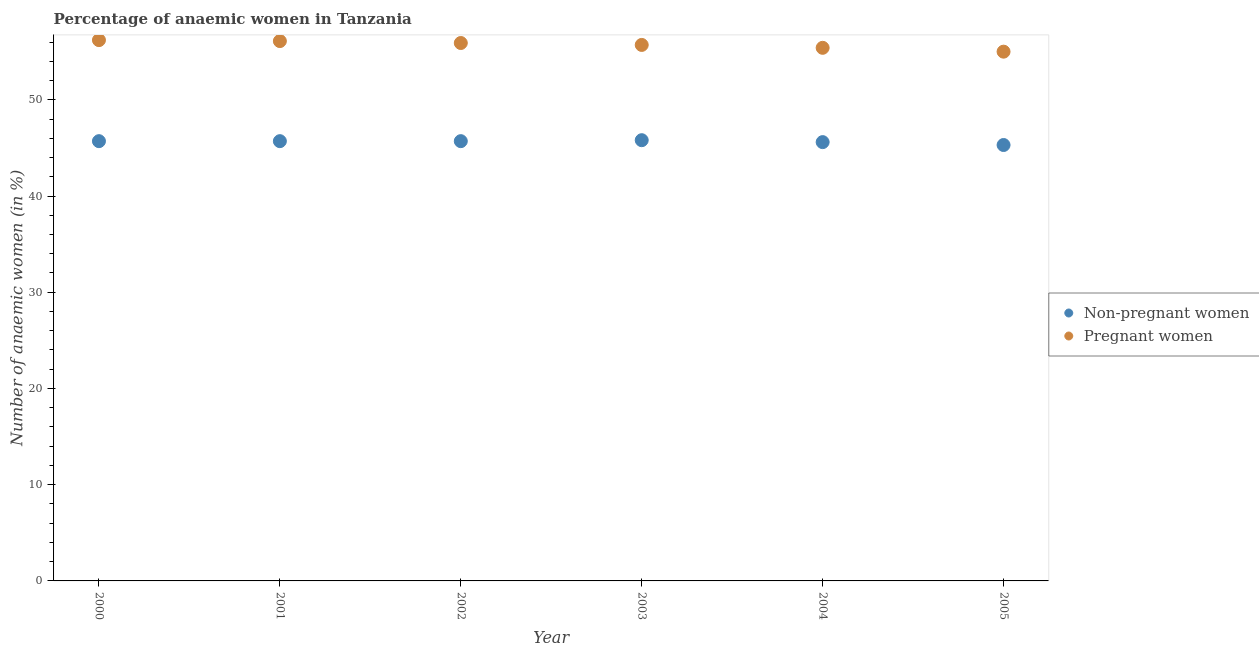Is the number of dotlines equal to the number of legend labels?
Your answer should be compact. Yes. What is the percentage of non-pregnant anaemic women in 2005?
Your answer should be compact. 45.3. Across all years, what is the maximum percentage of non-pregnant anaemic women?
Give a very brief answer. 45.8. Across all years, what is the minimum percentage of non-pregnant anaemic women?
Give a very brief answer. 45.3. In which year was the percentage of non-pregnant anaemic women minimum?
Offer a terse response. 2005. What is the total percentage of non-pregnant anaemic women in the graph?
Provide a succinct answer. 273.8. What is the difference between the percentage of pregnant anaemic women in 2000 and that in 2005?
Give a very brief answer. 1.2. What is the difference between the percentage of non-pregnant anaemic women in 2001 and the percentage of pregnant anaemic women in 2004?
Provide a succinct answer. -9.7. What is the average percentage of non-pregnant anaemic women per year?
Provide a succinct answer. 45.63. In the year 2005, what is the difference between the percentage of pregnant anaemic women and percentage of non-pregnant anaemic women?
Ensure brevity in your answer.  9.7. What is the ratio of the percentage of pregnant anaemic women in 2004 to that in 2005?
Provide a short and direct response. 1.01. Is the percentage of pregnant anaemic women in 2000 less than that in 2005?
Your answer should be compact. No. Is the difference between the percentage of non-pregnant anaemic women in 2001 and 2003 greater than the difference between the percentage of pregnant anaemic women in 2001 and 2003?
Your response must be concise. No. What is the difference between the highest and the second highest percentage of non-pregnant anaemic women?
Keep it short and to the point. 0.1. What is the difference between the highest and the lowest percentage of pregnant anaemic women?
Ensure brevity in your answer.  1.2. In how many years, is the percentage of non-pregnant anaemic women greater than the average percentage of non-pregnant anaemic women taken over all years?
Your answer should be very brief. 4. Is the sum of the percentage of non-pregnant anaemic women in 2000 and 2001 greater than the maximum percentage of pregnant anaemic women across all years?
Your response must be concise. Yes. Is the percentage of non-pregnant anaemic women strictly greater than the percentage of pregnant anaemic women over the years?
Keep it short and to the point. No. Is the percentage of non-pregnant anaemic women strictly less than the percentage of pregnant anaemic women over the years?
Your answer should be very brief. Yes. How many dotlines are there?
Offer a very short reply. 2. What is the difference between two consecutive major ticks on the Y-axis?
Ensure brevity in your answer.  10. Are the values on the major ticks of Y-axis written in scientific E-notation?
Offer a very short reply. No. Does the graph contain any zero values?
Give a very brief answer. No. Does the graph contain grids?
Your answer should be compact. No. How many legend labels are there?
Give a very brief answer. 2. How are the legend labels stacked?
Give a very brief answer. Vertical. What is the title of the graph?
Offer a terse response. Percentage of anaemic women in Tanzania. What is the label or title of the Y-axis?
Provide a succinct answer. Number of anaemic women (in %). What is the Number of anaemic women (in %) of Non-pregnant women in 2000?
Make the answer very short. 45.7. What is the Number of anaemic women (in %) of Pregnant women in 2000?
Your answer should be compact. 56.2. What is the Number of anaemic women (in %) of Non-pregnant women in 2001?
Provide a succinct answer. 45.7. What is the Number of anaemic women (in %) in Pregnant women in 2001?
Your response must be concise. 56.1. What is the Number of anaemic women (in %) of Non-pregnant women in 2002?
Offer a very short reply. 45.7. What is the Number of anaemic women (in %) in Pregnant women in 2002?
Ensure brevity in your answer.  55.9. What is the Number of anaemic women (in %) of Non-pregnant women in 2003?
Ensure brevity in your answer.  45.8. What is the Number of anaemic women (in %) of Pregnant women in 2003?
Your answer should be very brief. 55.7. What is the Number of anaemic women (in %) of Non-pregnant women in 2004?
Offer a terse response. 45.6. What is the Number of anaemic women (in %) of Pregnant women in 2004?
Provide a short and direct response. 55.4. What is the Number of anaemic women (in %) of Non-pregnant women in 2005?
Offer a very short reply. 45.3. What is the Number of anaemic women (in %) in Pregnant women in 2005?
Make the answer very short. 55. Across all years, what is the maximum Number of anaemic women (in %) of Non-pregnant women?
Keep it short and to the point. 45.8. Across all years, what is the maximum Number of anaemic women (in %) of Pregnant women?
Offer a terse response. 56.2. Across all years, what is the minimum Number of anaemic women (in %) of Non-pregnant women?
Ensure brevity in your answer.  45.3. What is the total Number of anaemic women (in %) of Non-pregnant women in the graph?
Your answer should be compact. 273.8. What is the total Number of anaemic women (in %) in Pregnant women in the graph?
Your answer should be very brief. 334.3. What is the difference between the Number of anaemic women (in %) in Pregnant women in 2000 and that in 2001?
Ensure brevity in your answer.  0.1. What is the difference between the Number of anaemic women (in %) in Pregnant women in 2000 and that in 2002?
Provide a succinct answer. 0.3. What is the difference between the Number of anaemic women (in %) of Pregnant women in 2000 and that in 2003?
Offer a very short reply. 0.5. What is the difference between the Number of anaemic women (in %) in Non-pregnant women in 2000 and that in 2004?
Provide a succinct answer. 0.1. What is the difference between the Number of anaemic women (in %) of Pregnant women in 2000 and that in 2004?
Give a very brief answer. 0.8. What is the difference between the Number of anaemic women (in %) in Pregnant women in 2000 and that in 2005?
Your answer should be very brief. 1.2. What is the difference between the Number of anaemic women (in %) in Non-pregnant women in 2001 and that in 2004?
Keep it short and to the point. 0.1. What is the difference between the Number of anaemic women (in %) of Pregnant women in 2001 and that in 2004?
Provide a succinct answer. 0.7. What is the difference between the Number of anaemic women (in %) of Non-pregnant women in 2002 and that in 2005?
Keep it short and to the point. 0.4. What is the difference between the Number of anaemic women (in %) of Pregnant women in 2002 and that in 2005?
Your answer should be compact. 0.9. What is the difference between the Number of anaemic women (in %) of Non-pregnant women in 2003 and that in 2004?
Your response must be concise. 0.2. What is the difference between the Number of anaemic women (in %) in Pregnant women in 2003 and that in 2004?
Provide a short and direct response. 0.3. What is the difference between the Number of anaemic women (in %) of Non-pregnant women in 2003 and that in 2005?
Give a very brief answer. 0.5. What is the difference between the Number of anaemic women (in %) of Non-pregnant women in 2004 and that in 2005?
Your response must be concise. 0.3. What is the difference between the Number of anaemic women (in %) of Pregnant women in 2004 and that in 2005?
Provide a succinct answer. 0.4. What is the difference between the Number of anaemic women (in %) in Non-pregnant women in 2000 and the Number of anaemic women (in %) in Pregnant women in 2002?
Your answer should be very brief. -10.2. What is the difference between the Number of anaemic women (in %) of Non-pregnant women in 2000 and the Number of anaemic women (in %) of Pregnant women in 2003?
Keep it short and to the point. -10. What is the difference between the Number of anaemic women (in %) in Non-pregnant women in 2000 and the Number of anaemic women (in %) in Pregnant women in 2005?
Keep it short and to the point. -9.3. What is the difference between the Number of anaemic women (in %) in Non-pregnant women in 2001 and the Number of anaemic women (in %) in Pregnant women in 2003?
Your answer should be very brief. -10. What is the difference between the Number of anaemic women (in %) in Non-pregnant women in 2001 and the Number of anaemic women (in %) in Pregnant women in 2004?
Your response must be concise. -9.7. What is the difference between the Number of anaemic women (in %) in Non-pregnant women in 2003 and the Number of anaemic women (in %) in Pregnant women in 2004?
Your answer should be very brief. -9.6. What is the difference between the Number of anaemic women (in %) of Non-pregnant women in 2004 and the Number of anaemic women (in %) of Pregnant women in 2005?
Ensure brevity in your answer.  -9.4. What is the average Number of anaemic women (in %) of Non-pregnant women per year?
Offer a terse response. 45.63. What is the average Number of anaemic women (in %) of Pregnant women per year?
Your response must be concise. 55.72. In the year 2000, what is the difference between the Number of anaemic women (in %) of Non-pregnant women and Number of anaemic women (in %) of Pregnant women?
Provide a succinct answer. -10.5. In the year 2003, what is the difference between the Number of anaemic women (in %) of Non-pregnant women and Number of anaemic women (in %) of Pregnant women?
Make the answer very short. -9.9. What is the ratio of the Number of anaemic women (in %) of Non-pregnant women in 2000 to that in 2001?
Ensure brevity in your answer.  1. What is the ratio of the Number of anaemic women (in %) of Pregnant women in 2000 to that in 2001?
Provide a succinct answer. 1. What is the ratio of the Number of anaemic women (in %) of Pregnant women in 2000 to that in 2002?
Offer a very short reply. 1.01. What is the ratio of the Number of anaemic women (in %) of Non-pregnant women in 2000 to that in 2003?
Offer a very short reply. 1. What is the ratio of the Number of anaemic women (in %) of Pregnant women in 2000 to that in 2003?
Your answer should be compact. 1.01. What is the ratio of the Number of anaemic women (in %) of Pregnant women in 2000 to that in 2004?
Provide a succinct answer. 1.01. What is the ratio of the Number of anaemic women (in %) of Non-pregnant women in 2000 to that in 2005?
Keep it short and to the point. 1.01. What is the ratio of the Number of anaemic women (in %) of Pregnant women in 2000 to that in 2005?
Offer a terse response. 1.02. What is the ratio of the Number of anaemic women (in %) of Pregnant women in 2001 to that in 2003?
Your response must be concise. 1.01. What is the ratio of the Number of anaemic women (in %) in Pregnant women in 2001 to that in 2004?
Make the answer very short. 1.01. What is the ratio of the Number of anaemic women (in %) in Non-pregnant women in 2001 to that in 2005?
Your answer should be very brief. 1.01. What is the ratio of the Number of anaemic women (in %) of Non-pregnant women in 2002 to that in 2004?
Provide a short and direct response. 1. What is the ratio of the Number of anaemic women (in %) in Pregnant women in 2002 to that in 2004?
Your response must be concise. 1.01. What is the ratio of the Number of anaemic women (in %) in Non-pregnant women in 2002 to that in 2005?
Your response must be concise. 1.01. What is the ratio of the Number of anaemic women (in %) of Pregnant women in 2002 to that in 2005?
Make the answer very short. 1.02. What is the ratio of the Number of anaemic women (in %) in Pregnant women in 2003 to that in 2004?
Keep it short and to the point. 1.01. What is the ratio of the Number of anaemic women (in %) of Pregnant women in 2003 to that in 2005?
Make the answer very short. 1.01. What is the ratio of the Number of anaemic women (in %) of Non-pregnant women in 2004 to that in 2005?
Ensure brevity in your answer.  1.01. What is the ratio of the Number of anaemic women (in %) in Pregnant women in 2004 to that in 2005?
Give a very brief answer. 1.01. What is the difference between the highest and the second highest Number of anaemic women (in %) of Non-pregnant women?
Make the answer very short. 0.1. What is the difference between the highest and the second highest Number of anaemic women (in %) of Pregnant women?
Provide a succinct answer. 0.1. What is the difference between the highest and the lowest Number of anaemic women (in %) of Pregnant women?
Ensure brevity in your answer.  1.2. 